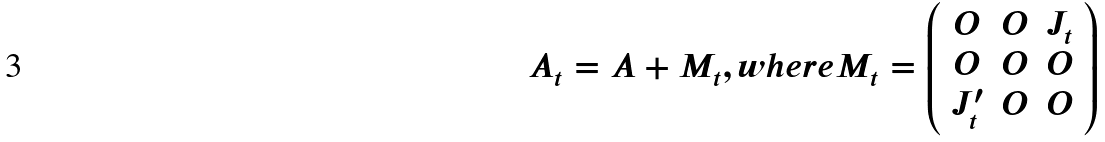<formula> <loc_0><loc_0><loc_500><loc_500>A _ { t } = A + M _ { t } , w h e r e M _ { t } = \left ( \begin{array} { c c c } O & O & J _ { t } \\ O & O & O \\ J _ { t } ^ { \prime } & O & O \end{array} \right )</formula> 